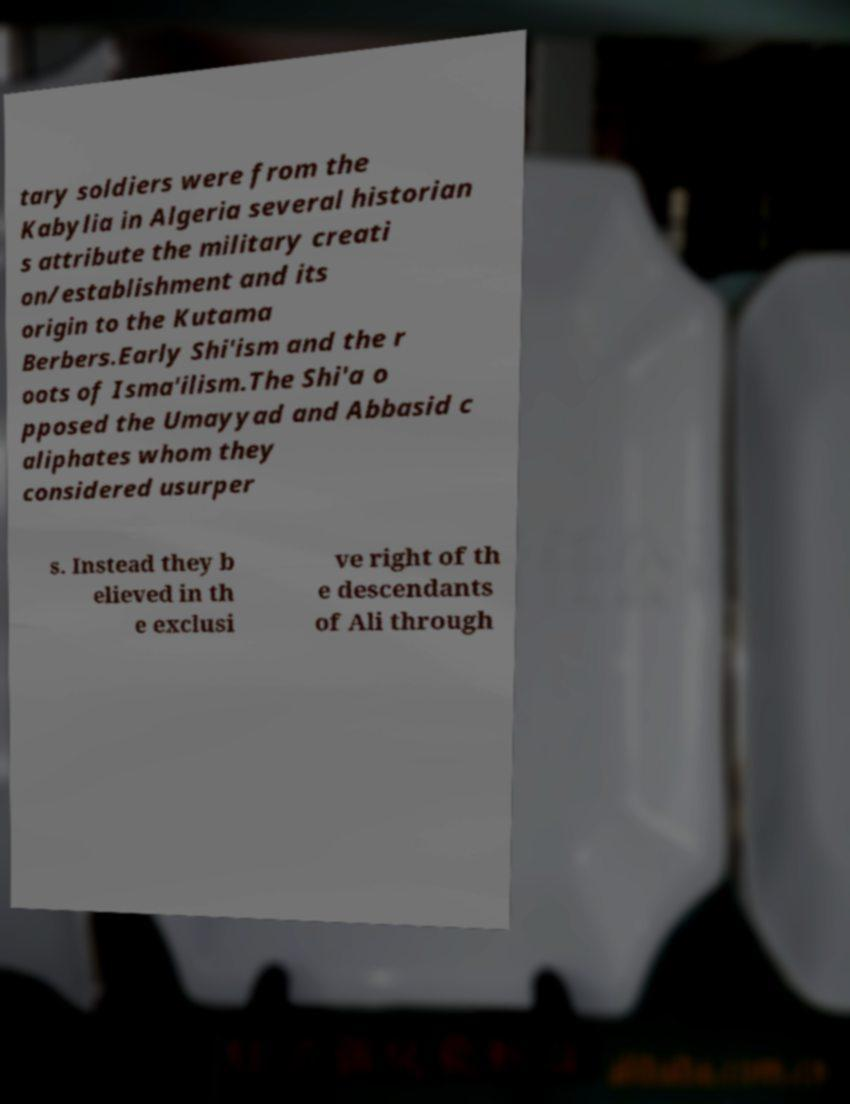Can you accurately transcribe the text from the provided image for me? tary soldiers were from the Kabylia in Algeria several historian s attribute the military creati on/establishment and its origin to the Kutama Berbers.Early Shi'ism and the r oots of Isma'ilism.The Shi'a o pposed the Umayyad and Abbasid c aliphates whom they considered usurper s. Instead they b elieved in th e exclusi ve right of th e descendants of Ali through 